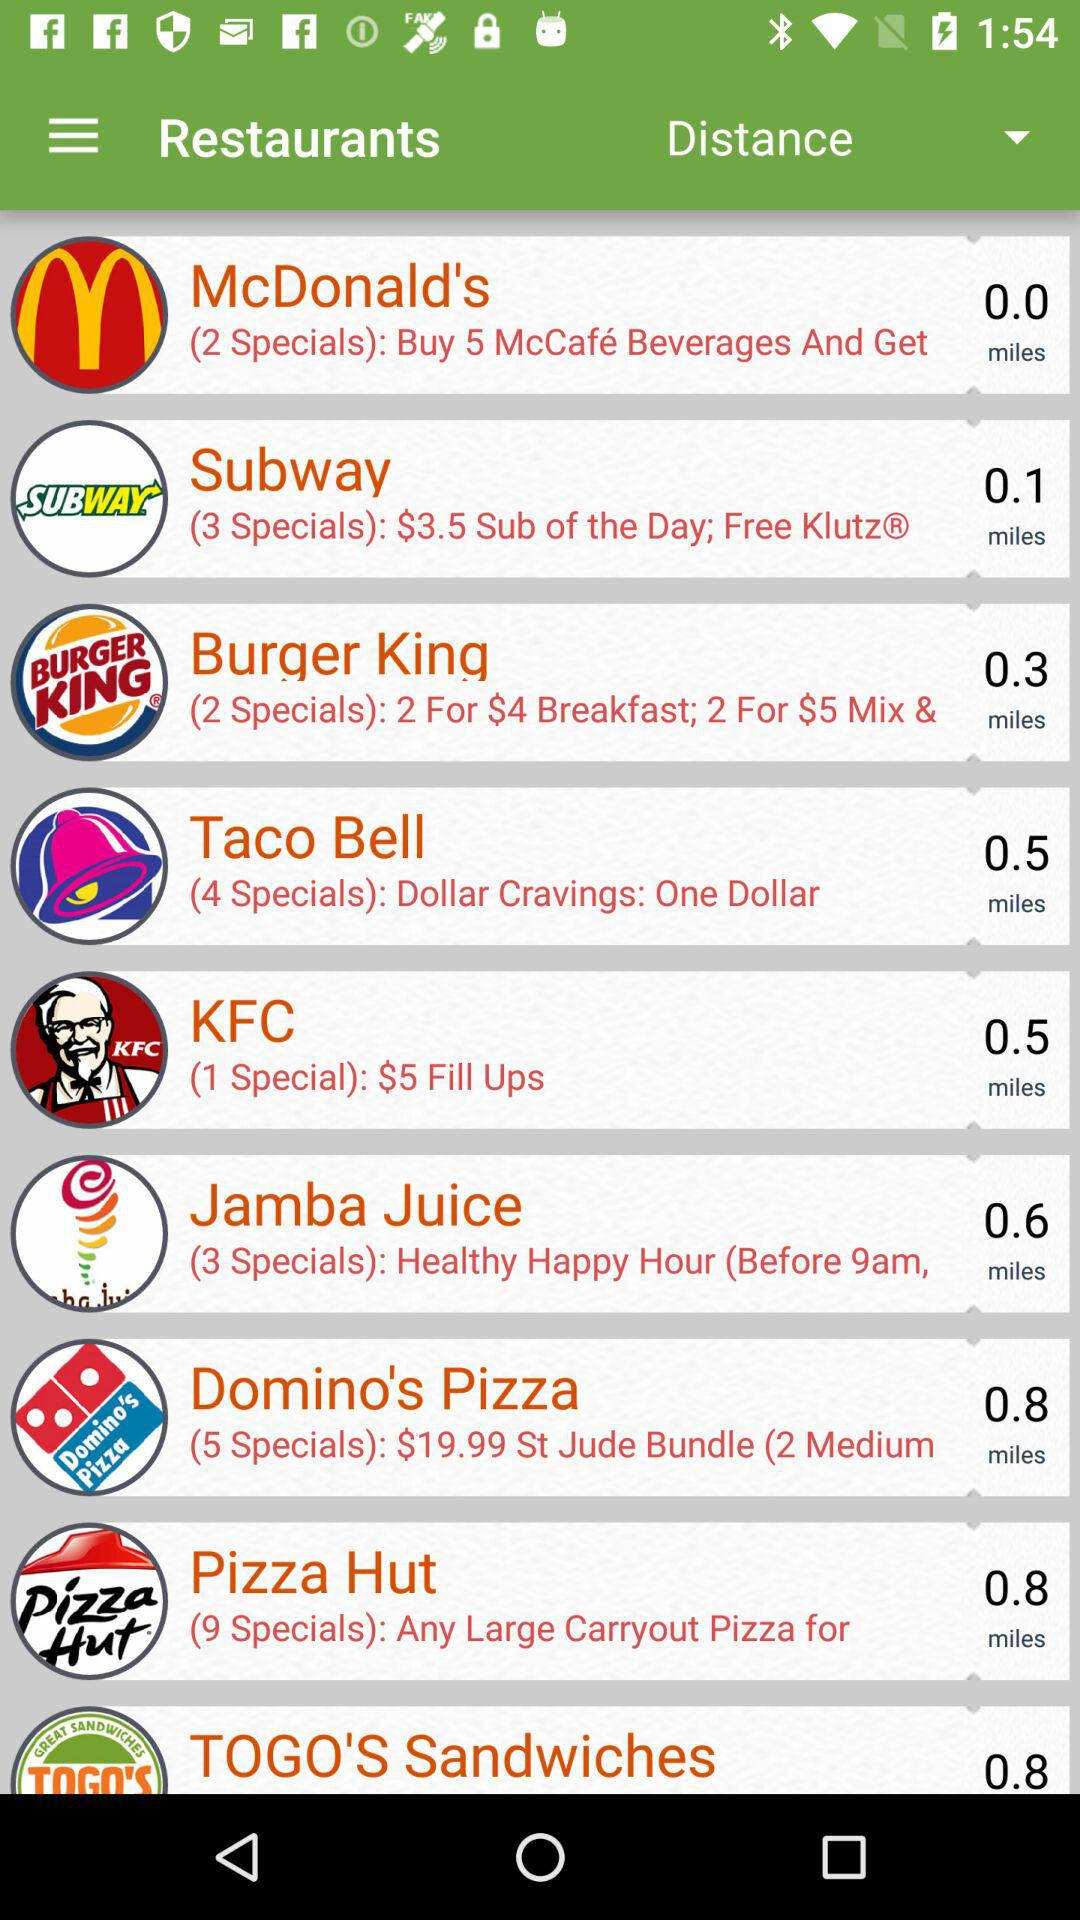What are the different restaurants available on the list? The different restaurants available on the list are McDonald's, Subway, Burger King, Taco Bell, KFC, Jamba Juice, Domino's Pizza, Pizza Hut and TOGO'S Sandwiches. 